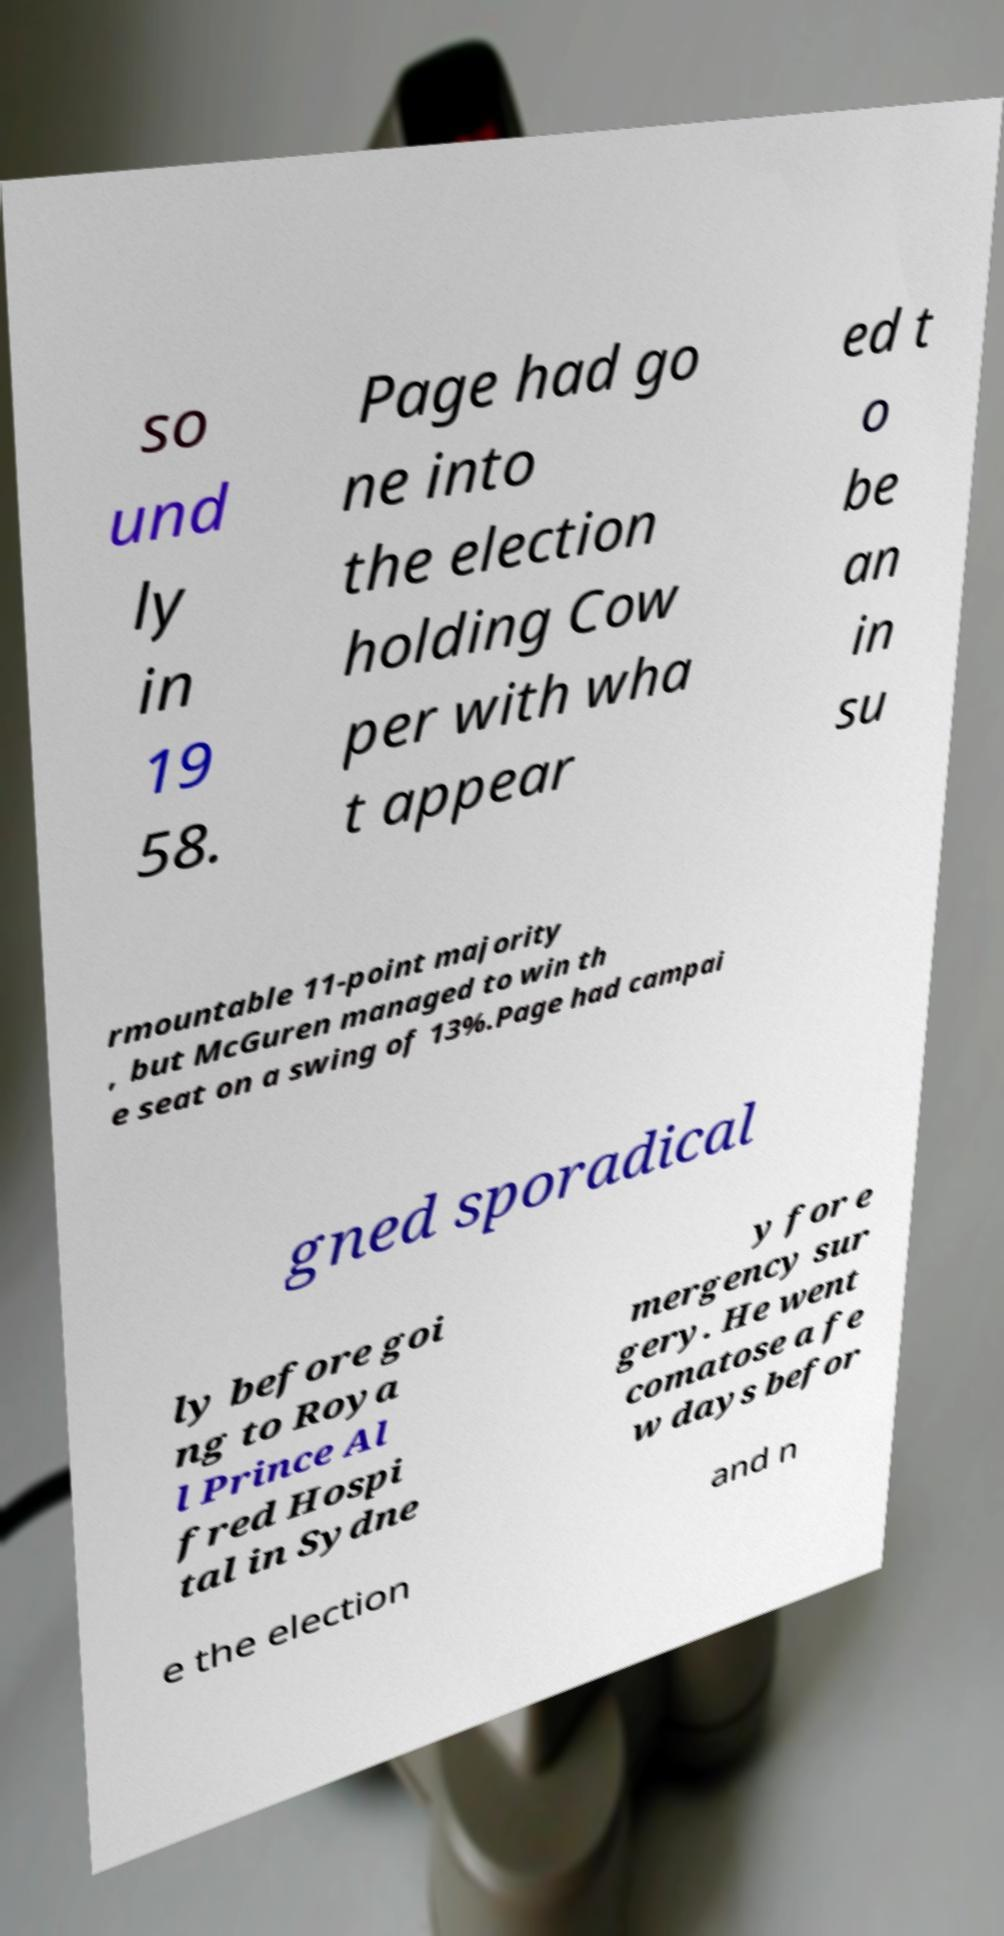Could you assist in decoding the text presented in this image and type it out clearly? so und ly in 19 58. Page had go ne into the election holding Cow per with wha t appear ed t o be an in su rmountable 11-point majority , but McGuren managed to win th e seat on a swing of 13%.Page had campai gned sporadical ly before goi ng to Roya l Prince Al fred Hospi tal in Sydne y for e mergency sur gery. He went comatose a fe w days befor e the election and n 